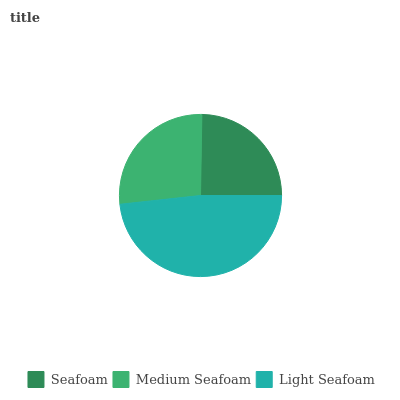Is Seafoam the minimum?
Answer yes or no. Yes. Is Light Seafoam the maximum?
Answer yes or no. Yes. Is Medium Seafoam the minimum?
Answer yes or no. No. Is Medium Seafoam the maximum?
Answer yes or no. No. Is Medium Seafoam greater than Seafoam?
Answer yes or no. Yes. Is Seafoam less than Medium Seafoam?
Answer yes or no. Yes. Is Seafoam greater than Medium Seafoam?
Answer yes or no. No. Is Medium Seafoam less than Seafoam?
Answer yes or no. No. Is Medium Seafoam the high median?
Answer yes or no. Yes. Is Medium Seafoam the low median?
Answer yes or no. Yes. Is Seafoam the high median?
Answer yes or no. No. Is Light Seafoam the low median?
Answer yes or no. No. 